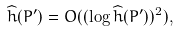Convert formula to latex. <formula><loc_0><loc_0><loc_500><loc_500>\widehat { h } ( P ^ { \prime } ) = O ( ( \log \widehat { h } ( P ^ { \prime } ) ) ^ { 2 } ) ,</formula> 